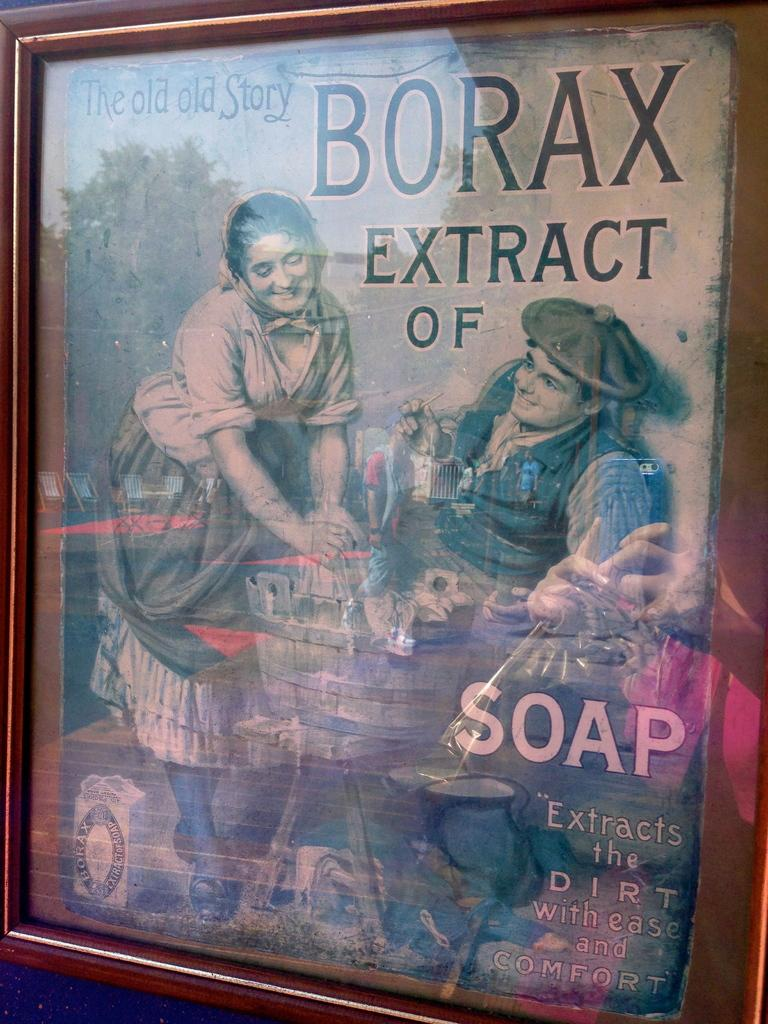Provide a one-sentence caption for the provided image. Book which is called the old story of Borax. 